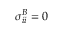Convert formula to latex. <formula><loc_0><loc_0><loc_500><loc_500>\sigma _ { i i } ^ { B } = 0</formula> 